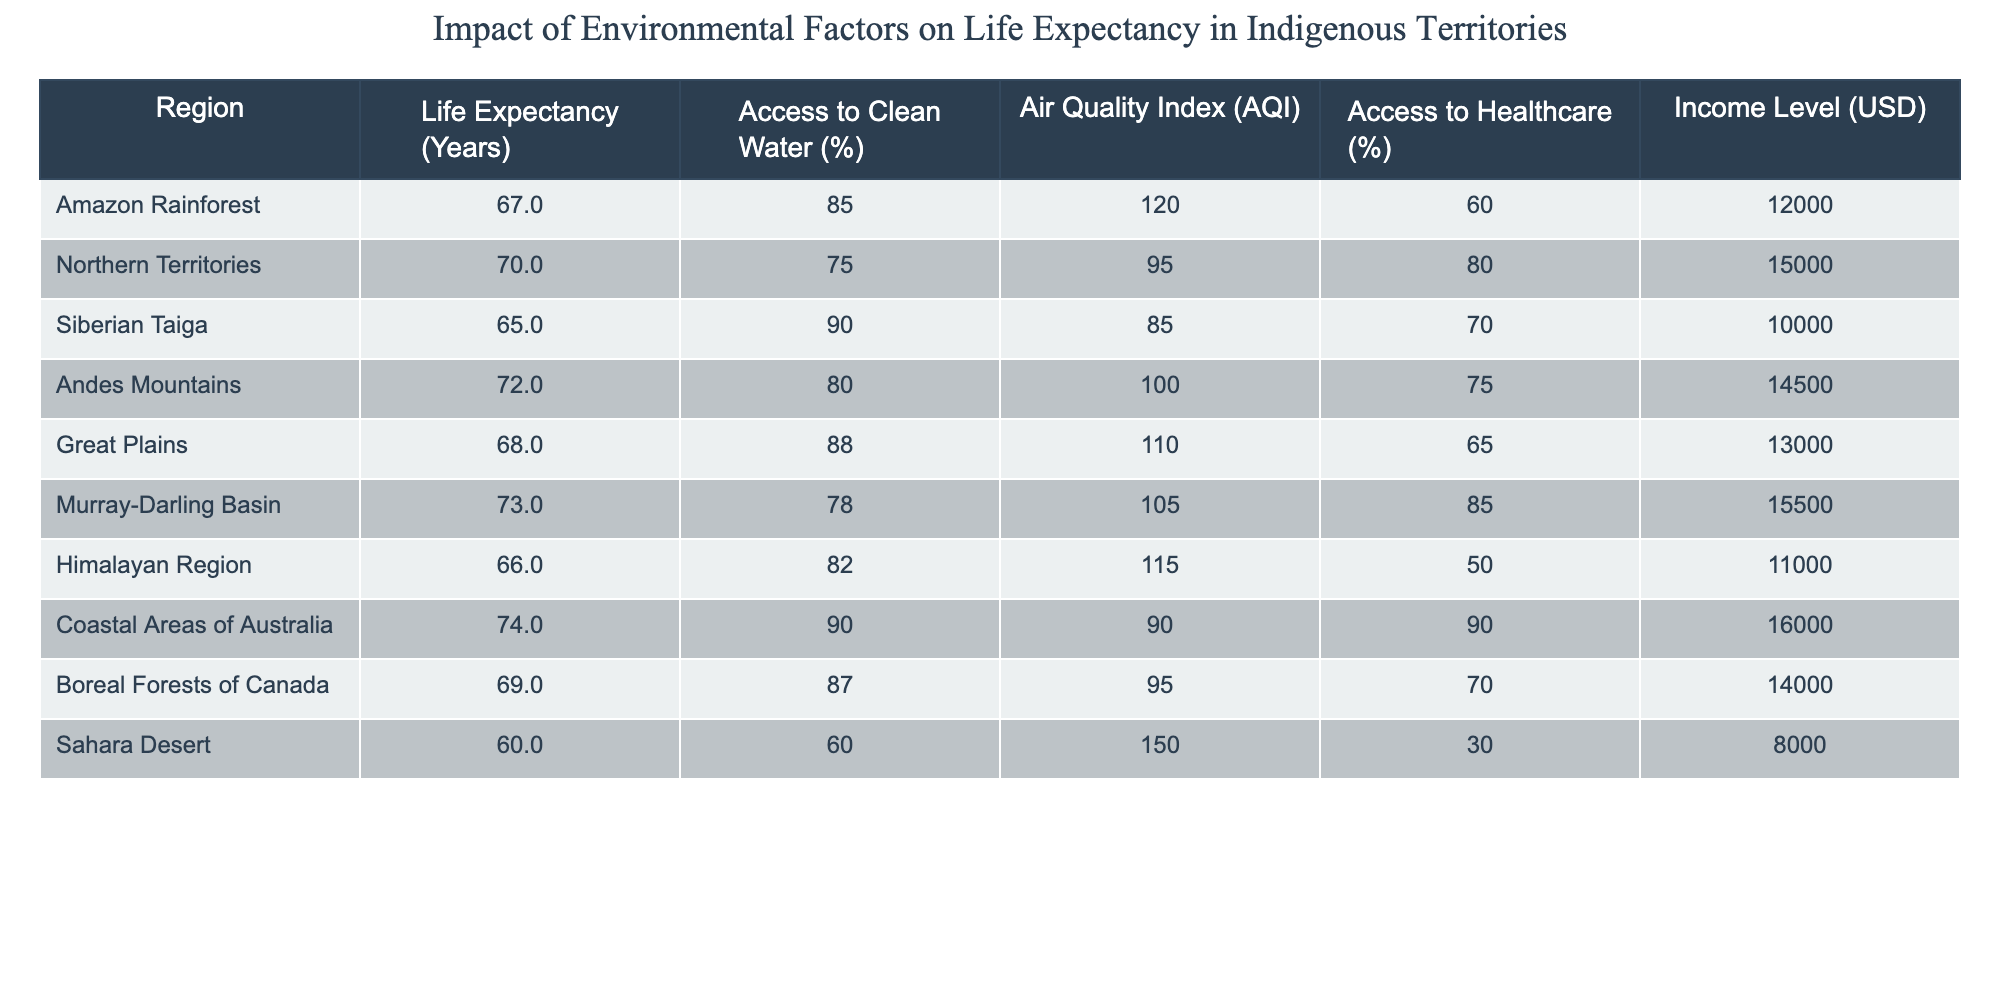What is the life expectancy in the Sahara Desert? According to the table, the life expectancy for the Sahara Desert is listed as 60 years. This is directly retrievable from the specific row corresponding to the Sahara Desert.
Answer: 60 Which region has the highest access to clean water percentage? From the table, the Coastal Areas of Australia have the highest access to clean water percentage at 90%. This can be identified by comparing the access to clean water percentages across all regions.
Answer: 90 What is the average life expectancy for regions with access to healthcare greater than 80%? The regions with access to healthcare greater than 80% are Northern Territories (70 years), Andes Mountains (72 years), and Murray-Darling Basin (73 years). Adding these together gives 70 + 72 + 73 = 215 years. Dividing by 3, the average life expectancy is 215/3 = 71.67 years.
Answer: 71.67 Is it true that regions with higher income levels have better air quality index ratings? To determine this, we look at the income levels and air quality index ratings. The Coastal Areas of Australia have the highest income level (16000) and the best AQI (90), while the Sahara Desert has the lowest income level (8000) and the worst AQI (150). The other regions also show a trend where higher income tends to correspond to lower AQI. Thus, the statement is true based on the data provided.
Answer: Yes What is the difference in life expectancy between the Amazon Rainforest and the Coastal Areas of Australia? The life expectancy of the Amazon Rainforest is 67 years and for the Coastal Areas of Australia, it is 74 years. Subtracting these two gives 74 - 67 = 7 years. Thus, the difference in life expectancy is 7 years.
Answer: 7 Which region has the lowest access to healthcare and what is that value? The data indicates that the region with the lowest access to healthcare percentage is the Sahara Desert, with only 30% access. This can be confirmed by scanning the healthcare values in the table and identifying the minimum.
Answer: 30 What is the median life expectancy of all regions listed? To find the median, first list the life expectancy values in order: 60, 65, 66, 67, 68, 69, 70, 72, 73, 74. Since there are 10 regions, the median will be the average of the 5th and 6th values, which are 68 and 69. Therefore, the median is (68 + 69) / 2 = 68.5.
Answer: 68.5 Is there any region with a life expectancy less than 65 years? Checking the table, only the Sahara Desert has a life expectancy of 60 years, which is indeed less than 65 years. Therefore, the answer to the question is confirmed as true.
Answer: Yes What is the total income level of the regions with life expectancy above the average life expectancy of all regions? First, we need to calculate the average life expectancy: (67 + 70 + 65 + 72 + 68 + 73 + 66 + 74 + 69 + 60) / 10 = 68.5 years. The regions above this average are Northern Territories (15000), Andes Mountains (14500), Murray-Darling Basin (15500), and Coastal Areas of Australia (16000). Summing those gives 15000 + 14500 + 15500 + 16000 = 61000.
Answer: 61000 